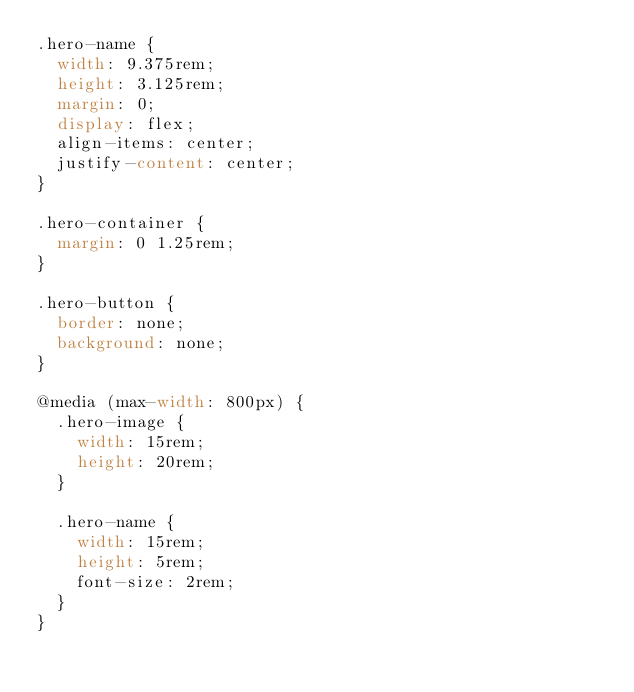<code> <loc_0><loc_0><loc_500><loc_500><_CSS_>.hero-name {
  width: 9.375rem;
  height: 3.125rem;
  margin: 0;
  display: flex;
  align-items: center;
  justify-content: center;
}

.hero-container {
  margin: 0 1.25rem;
}

.hero-button {
  border: none;
  background: none;
}

@media (max-width: 800px) {
  .hero-image {
    width: 15rem;
    height: 20rem;
  }

  .hero-name {
    width: 15rem;
    height: 5rem;
    font-size: 2rem;
  }
}
</code> 